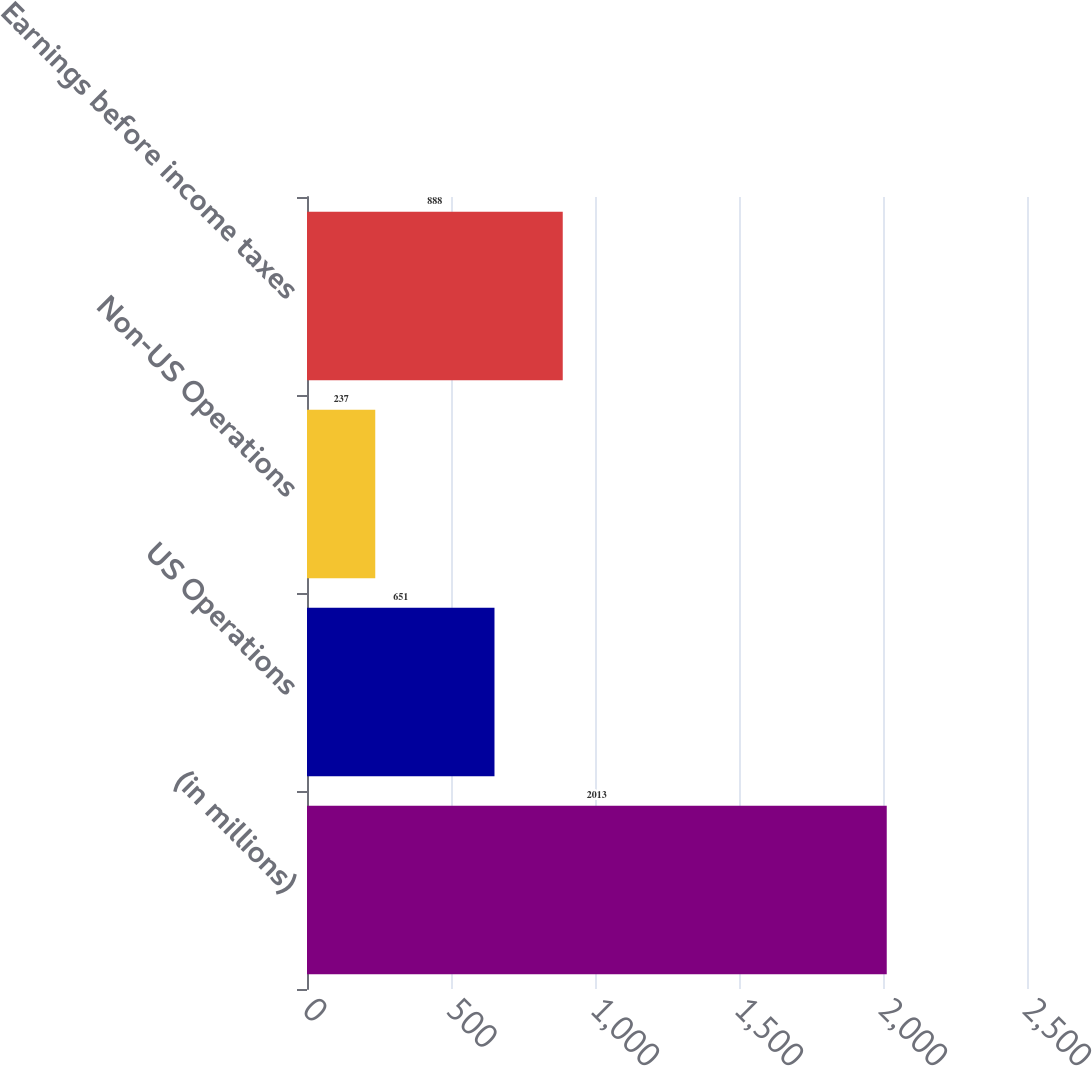Convert chart to OTSL. <chart><loc_0><loc_0><loc_500><loc_500><bar_chart><fcel>(in millions)<fcel>US Operations<fcel>Non-US Operations<fcel>Earnings before income taxes<nl><fcel>2013<fcel>651<fcel>237<fcel>888<nl></chart> 